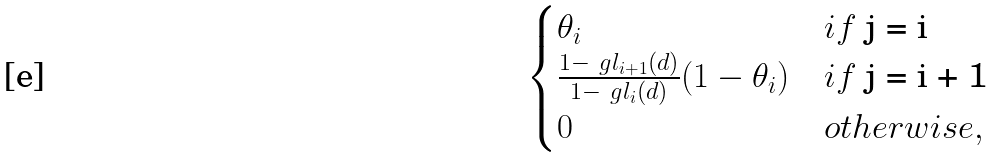Convert formula to latex. <formula><loc_0><loc_0><loc_500><loc_500>\begin{cases} \theta _ { i } & i f $ j = i $ \\ \frac { 1 - \ g l _ { i + 1 } ( d ) } { 1 - \ g l _ { i } ( d ) } ( 1 - \theta _ { i } ) & i f $ j = i + 1 $ \\ 0 & o t h e r w i s e , \end{cases}</formula> 